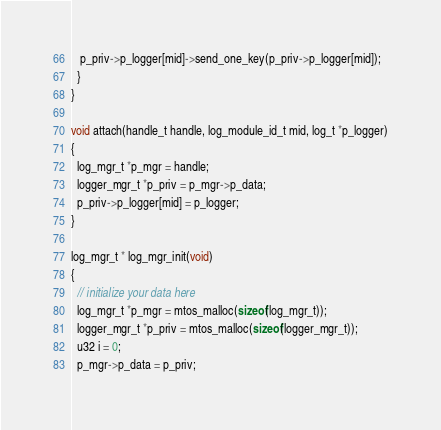<code> <loc_0><loc_0><loc_500><loc_500><_C_>   p_priv->p_logger[mid]->send_one_key(p_priv->p_logger[mid]);
  }
}

void attach(handle_t handle, log_module_id_t mid, log_t *p_logger)
{
  log_mgr_t *p_mgr = handle;
  logger_mgr_t *p_priv = p_mgr->p_data;
  p_priv->p_logger[mid] = p_logger;
}

log_mgr_t * log_mgr_init(void)
{
  // initialize your data here
  log_mgr_t *p_mgr = mtos_malloc(sizeof(log_mgr_t));
  logger_mgr_t *p_priv = mtos_malloc(sizeof(logger_mgr_t));
  u32 i = 0;
  p_mgr->p_data = p_priv;</code> 